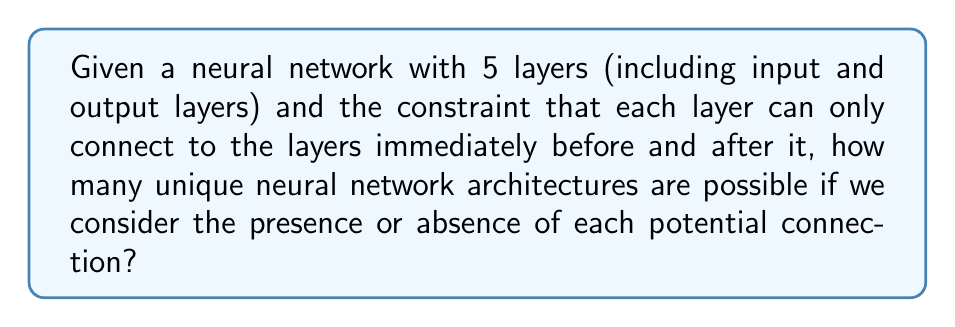What is the answer to this math problem? Let's approach this step-by-step:

1) First, we need to count the number of potential connections between layers:
   - Between layer 1 and 2: 1 connection
   - Between layer 2 and 3: 1 connection
   - Between layer 3 and 4: 1 connection
   - Between layer 4 and 5: 1 connection
   Total: 4 potential connections

2) For each of these connections, we have two choices: it can either be present or absent.

3) This scenario can be modeled as a binary choice for each connection. In combinatorics, when we have n independent binary choices, the total number of possibilities is $2^n$.

4) In this case, we have 4 independent binary choices (one for each potential connection).

5) Therefore, the total number of unique neural network architectures is:

   $$ 2^4 = 16 $$

This means there are 16 possible unique architectures, ranging from a network with no connections at all to a fully connected network (within the given constraints).
Answer: $2^4 = 16$ 